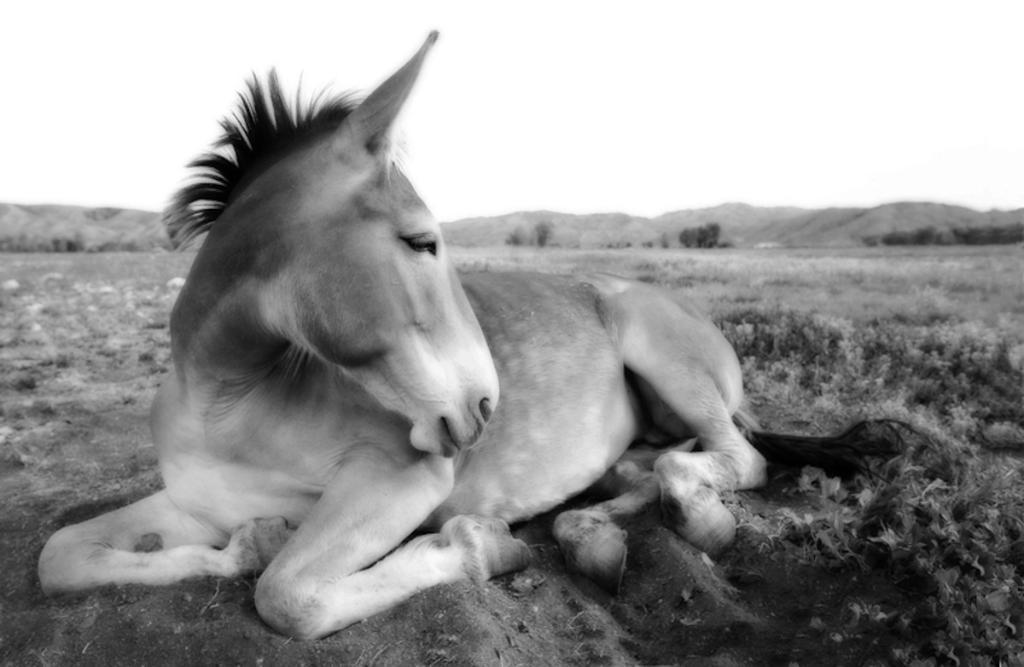Can you describe this image briefly? In this picture we can see an animal on the ground and in the background we can see trees, mountains, sky. 